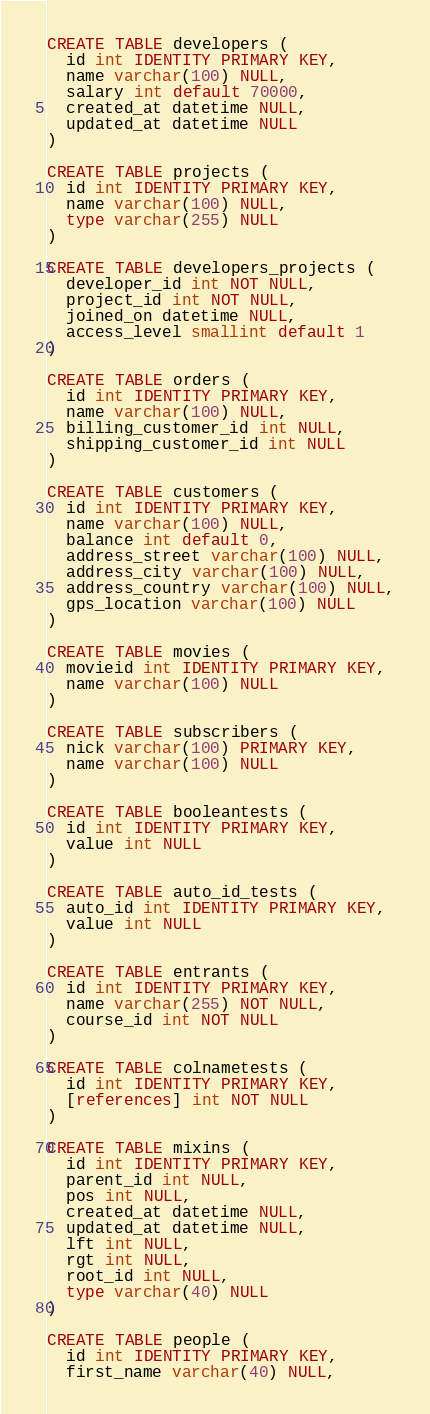<code> <loc_0><loc_0><loc_500><loc_500><_SQL_>
CREATE TABLE developers (
  id int IDENTITY PRIMARY KEY,
  name varchar(100) NULL,
  salary int default 70000,
  created_at datetime NULL,
  updated_at datetime NULL
)

CREATE TABLE projects (
  id int IDENTITY PRIMARY KEY,
  name varchar(100) NULL,
  type varchar(255) NULL
)

CREATE TABLE developers_projects (
  developer_id int NOT NULL,
  project_id int NOT NULL,
  joined_on datetime NULL,
  access_level smallint default 1
)

CREATE TABLE orders (
  id int IDENTITY PRIMARY KEY,
  name varchar(100) NULL,
  billing_customer_id int NULL,
  shipping_customer_id int NULL
)

CREATE TABLE customers (
  id int IDENTITY PRIMARY KEY,
  name varchar(100) NULL,
  balance int default 0,
  address_street varchar(100) NULL,
  address_city varchar(100) NULL,
  address_country varchar(100) NULL,
  gps_location varchar(100) NULL
)

CREATE TABLE movies (
  movieid int IDENTITY PRIMARY KEY,
  name varchar(100) NULL
)

CREATE TABLE subscribers (
  nick varchar(100) PRIMARY KEY,
  name varchar(100) NULL
)

CREATE TABLE booleantests (
  id int IDENTITY PRIMARY KEY,
  value int NULL
)

CREATE TABLE auto_id_tests (
  auto_id int IDENTITY PRIMARY KEY,
  value int NULL
)

CREATE TABLE entrants (
  id int IDENTITY PRIMARY KEY,
  name varchar(255) NOT NULL,
  course_id int NOT NULL
)

CREATE TABLE colnametests (
  id int IDENTITY PRIMARY KEY,
  [references] int NOT NULL
)

CREATE TABLE mixins (
  id int IDENTITY PRIMARY KEY,
  parent_id int NULL,
  pos int NULL,
  created_at datetime NULL,
  updated_at datetime NULL,
  lft int NULL,
  rgt int NULL,
  root_id int NULL,
  type varchar(40) NULL
)

CREATE TABLE people (
  id int IDENTITY PRIMARY KEY,
  first_name varchar(40) NULL,</code> 